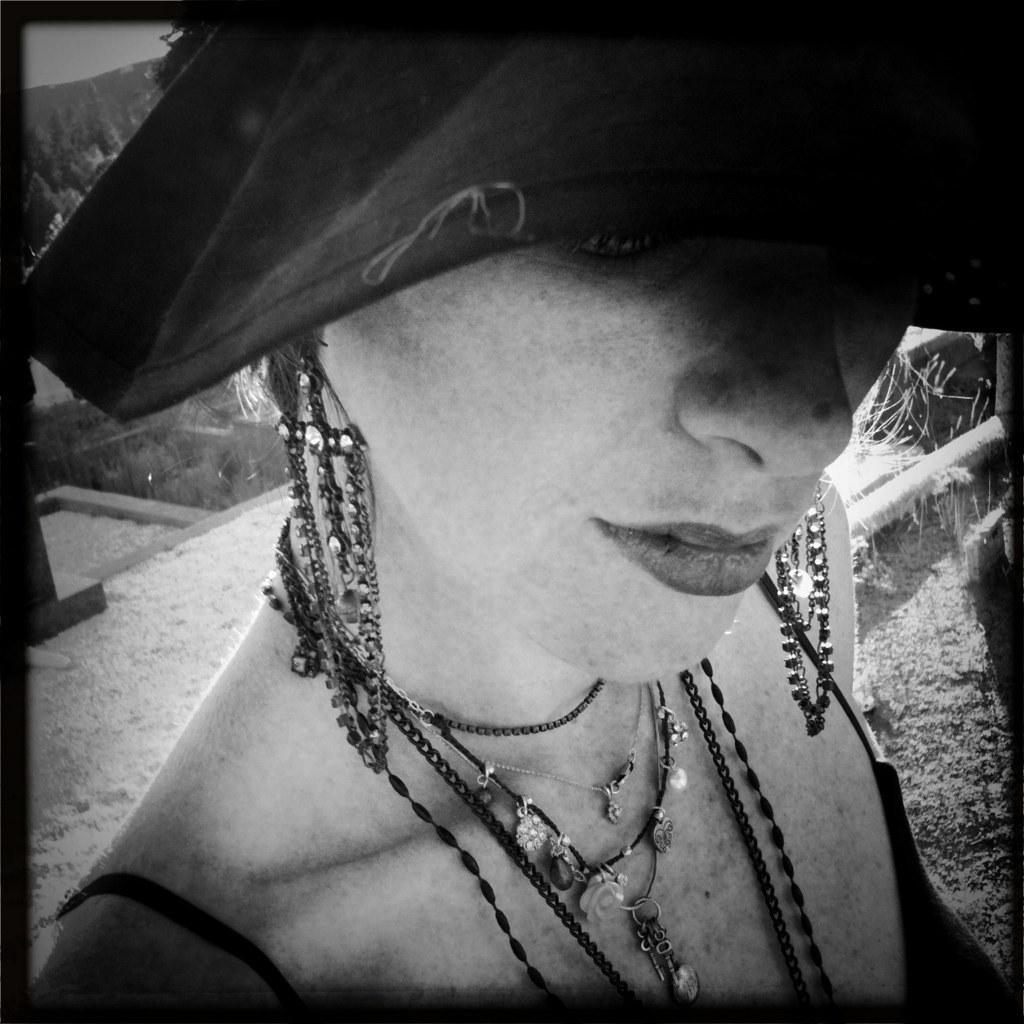What is the color scheme of the image? The image is black and white. Who is present in the image? There is a woman in the image. What is the woman wearing on her upper body? The woman is wearing a top. What accessories is the woman wearing? The woman is wearing jewelry. What headwear is the woman wearing? The woman is wearing a hat. What type of terrain is visible in the background of the image? There is land visible in the background of the image. What type of yam is the woman holding in the image? There is no yam present in the image. How many nails can be seen in the image? There are no nails visible in the image. 